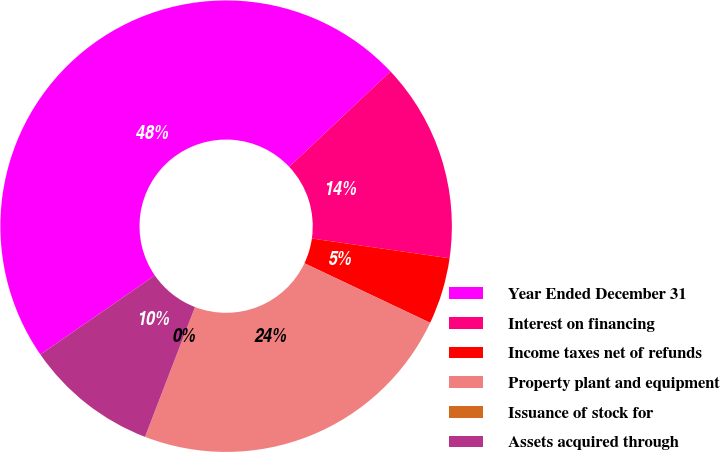Convert chart. <chart><loc_0><loc_0><loc_500><loc_500><pie_chart><fcel>Year Ended December 31<fcel>Interest on financing<fcel>Income taxes net of refunds<fcel>Property plant and equipment<fcel>Issuance of stock for<fcel>Assets acquired through<nl><fcel>47.6%<fcel>14.29%<fcel>4.77%<fcel>23.8%<fcel>0.01%<fcel>9.53%<nl></chart> 